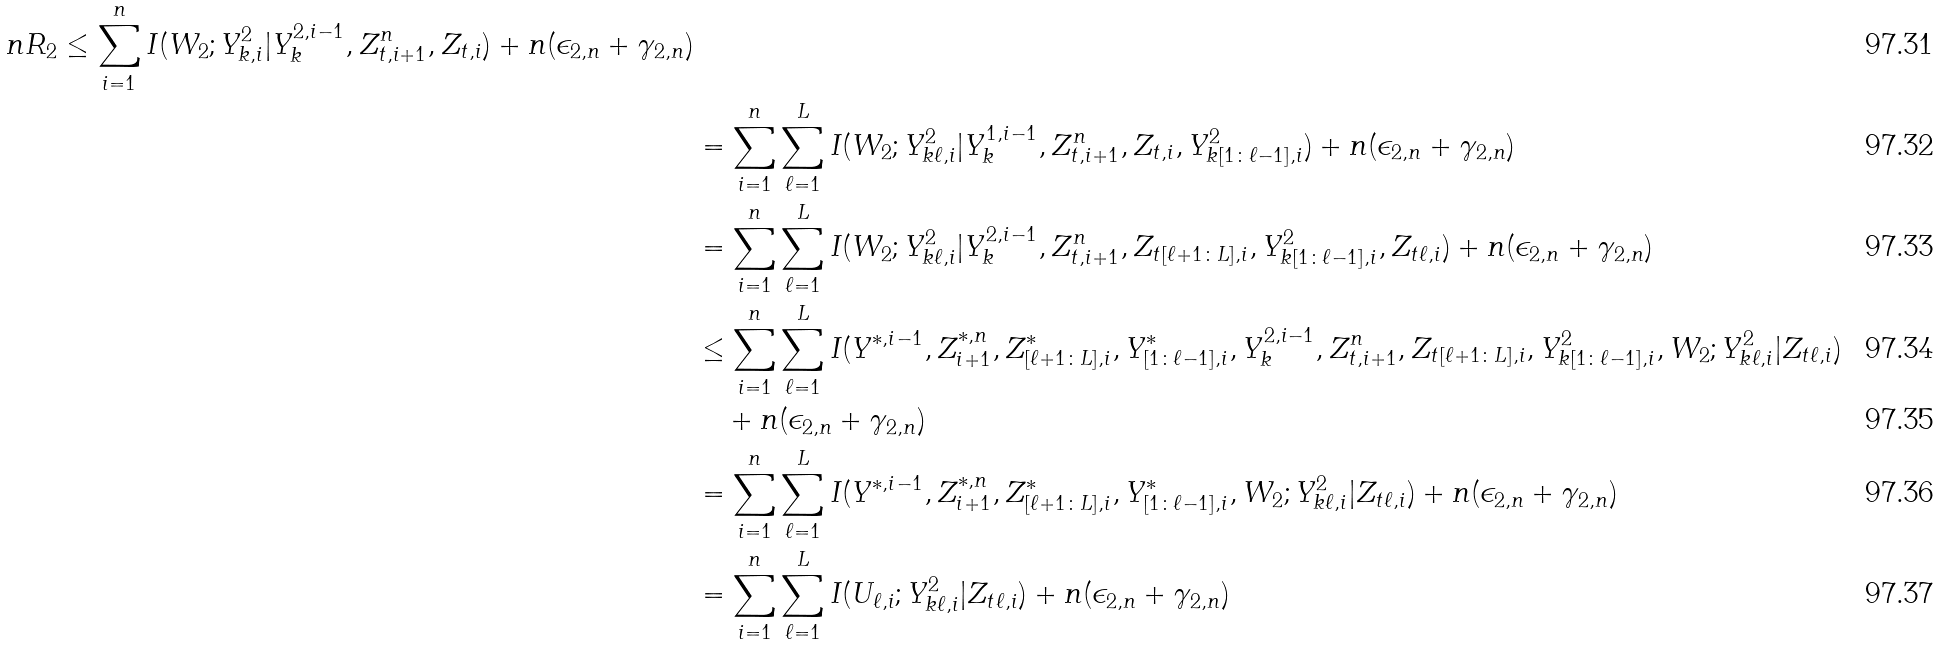<formula> <loc_0><loc_0><loc_500><loc_500>{ n R _ { 2 } \leq \sum _ { i = 1 } ^ { n } I ( W _ { 2 } ; Y _ { k , i } ^ { 2 } | Y _ { k } ^ { 2 , i - 1 } , Z _ { t , i + 1 } ^ { n } , Z _ { t , i } ) + n ( \epsilon _ { 2 , n } + \gamma _ { 2 , n } ) } \\ & = \sum _ { i = 1 } ^ { n } \sum _ { \ell = 1 } ^ { L } I ( W _ { 2 } ; Y _ { k \ell , i } ^ { 2 } | Y _ { k } ^ { 1 , i - 1 } , Z _ { t , i + 1 } ^ { n } , Z _ { t , i } , Y _ { k [ 1 \colon \ell - 1 ] , i } ^ { 2 } ) + n ( \epsilon _ { 2 , n } + \gamma _ { 2 , n } ) \\ & = \sum _ { i = 1 } ^ { n } \sum _ { \ell = 1 } ^ { L } I ( W _ { 2 } ; Y _ { k \ell , i } ^ { 2 } | Y _ { k } ^ { 2 , i - 1 } , Z _ { t , i + 1 } ^ { n } , Z _ { t [ \ell + 1 \colon L ] , i } , Y _ { k [ 1 \colon \ell - 1 ] , i } ^ { 2 } , Z _ { t \ell , i } ) + n ( \epsilon _ { 2 , n } + \gamma _ { 2 , n } ) \\ & \leq \sum _ { i = 1 } ^ { n } \sum _ { \ell = 1 } ^ { L } I ( Y ^ { * , i - 1 } , Z _ { i + 1 } ^ { * , n } , Z _ { [ \ell + 1 \colon L ] , i } ^ { * } , Y _ { [ 1 \colon \ell - 1 ] , i } ^ { * } , Y _ { k } ^ { 2 , i - 1 } , Z _ { t , i + 1 } ^ { n } , Z _ { t [ \ell + 1 \colon L ] , i } , Y _ { k [ 1 \colon \ell - 1 ] , i } ^ { 2 } , W _ { 2 } ; Y _ { k \ell , i } ^ { 2 } | Z _ { t \ell , i } ) \\ & \quad + n ( \epsilon _ { 2 , n } + \gamma _ { 2 , n } ) \\ & = \sum _ { i = 1 } ^ { n } \sum _ { \ell = 1 } ^ { L } I ( Y ^ { * , i - 1 } , Z _ { i + 1 } ^ { * , n } , Z _ { [ \ell + 1 \colon L ] , i } ^ { * } , Y _ { [ 1 \colon \ell - 1 ] , i } ^ { * } , W _ { 2 } ; Y _ { k \ell , i } ^ { 2 } | Z _ { t \ell , i } ) + n ( \epsilon _ { 2 , n } + \gamma _ { 2 , n } ) \\ & = \sum _ { i = 1 } ^ { n } \sum _ { \ell = 1 } ^ { L } I ( U _ { \ell , i } ; Y _ { k \ell , i } ^ { 2 } | Z _ { t \ell , i } ) + n ( \epsilon _ { 2 , n } + \gamma _ { 2 , n } )</formula> 